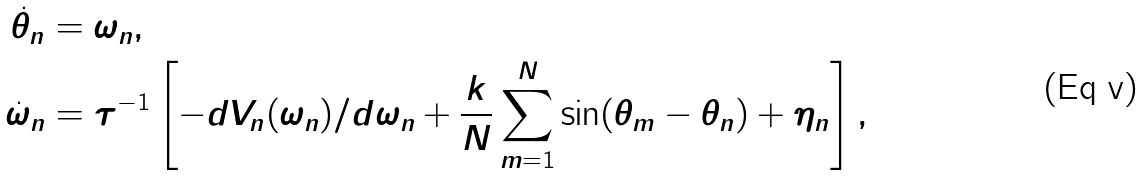<formula> <loc_0><loc_0><loc_500><loc_500>\dot { \theta } _ { n } & = \omega _ { n } , \\ \dot { \omega } _ { n } & = \tau ^ { - 1 } \left [ - d V _ { n } ( \omega _ { n } ) / d \omega _ { n } + \frac { k } { N } \sum _ { m = 1 } ^ { N } \sin ( \theta _ { m } - \theta _ { n } ) + \eta _ { n } \right ] ,</formula> 